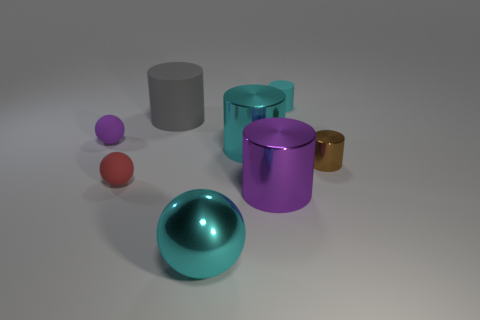Subtract 1 cylinders. How many cylinders are left? 4 Subtract all gray cylinders. How many cylinders are left? 4 Subtract all cyan metallic cylinders. How many cylinders are left? 4 Subtract all purple cylinders. Subtract all purple blocks. How many cylinders are left? 4 Add 1 green metal cylinders. How many objects exist? 9 Subtract all cylinders. How many objects are left? 3 Subtract all cyan metal balls. Subtract all small gray spheres. How many objects are left? 7 Add 3 large cyan metallic spheres. How many large cyan metallic spheres are left? 4 Add 1 tiny cylinders. How many tiny cylinders exist? 3 Subtract 0 yellow cubes. How many objects are left? 8 